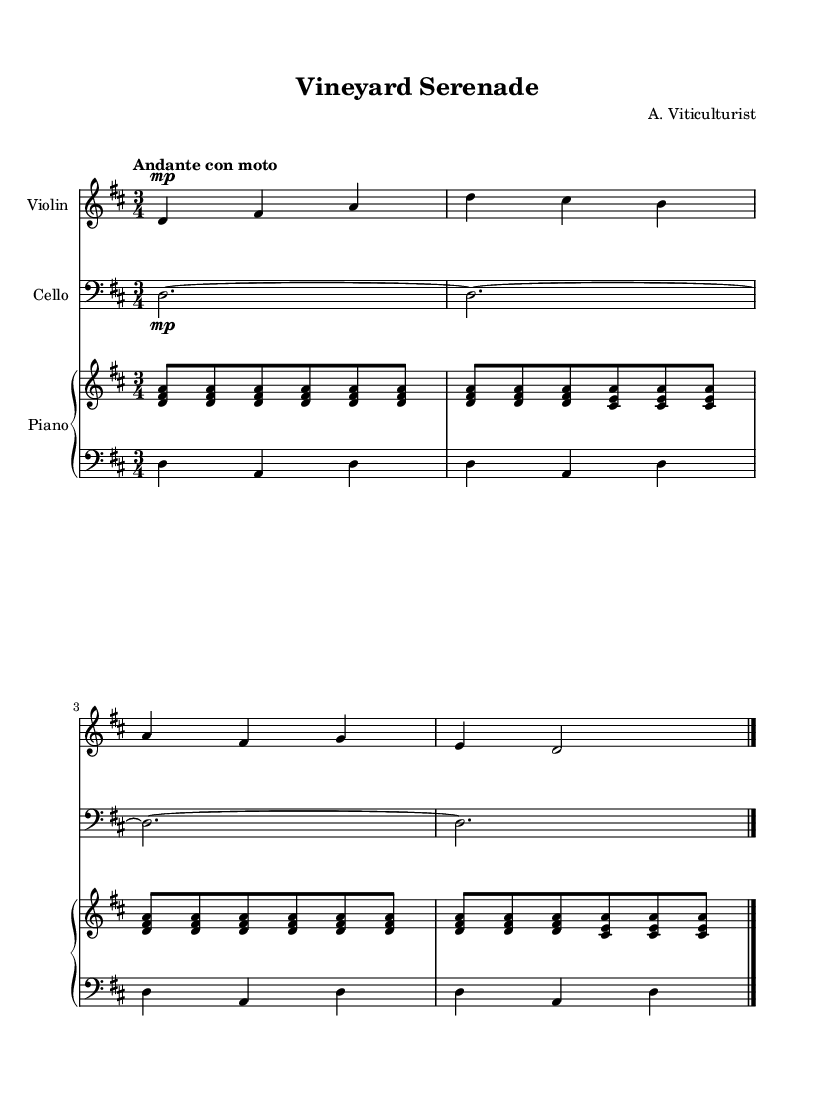What is the key signature of this music? The key signature is D major, which has two sharps (F# and C#).
Answer: D major What is the time signature of this music? The time signature is 3/4, indicating three beats per measure, with each beat represented by a quarter note.
Answer: 3/4 What is the tempo marking indicated in the score? The tempo marking is "Andante con moto," which suggests a moderately slow tempo with some movement.
Answer: Andante con moto How many measures are in the violin part? The violin part contains four measures, as indicated by the grouping of notes and the bar lines.
Answer: Four What instruments are included in this chamber music? The instruments included are violin, cello, and piano (two staffs for piano).
Answer: Violin, cello, piano Explain how the piano's right hand differs from the left hand in this piece. The right hand primarily plays chords in a repeating pattern with eighth notes, while the left hand provides a bass line with quarter notes, creating harmonic support.
Answer: Chords and bass line Which instrument carries the melody throughout the piece? The violin carries the melody, as it plays the most prominent and expressive line compared to the supportive parts of the cello and piano.
Answer: Violin 